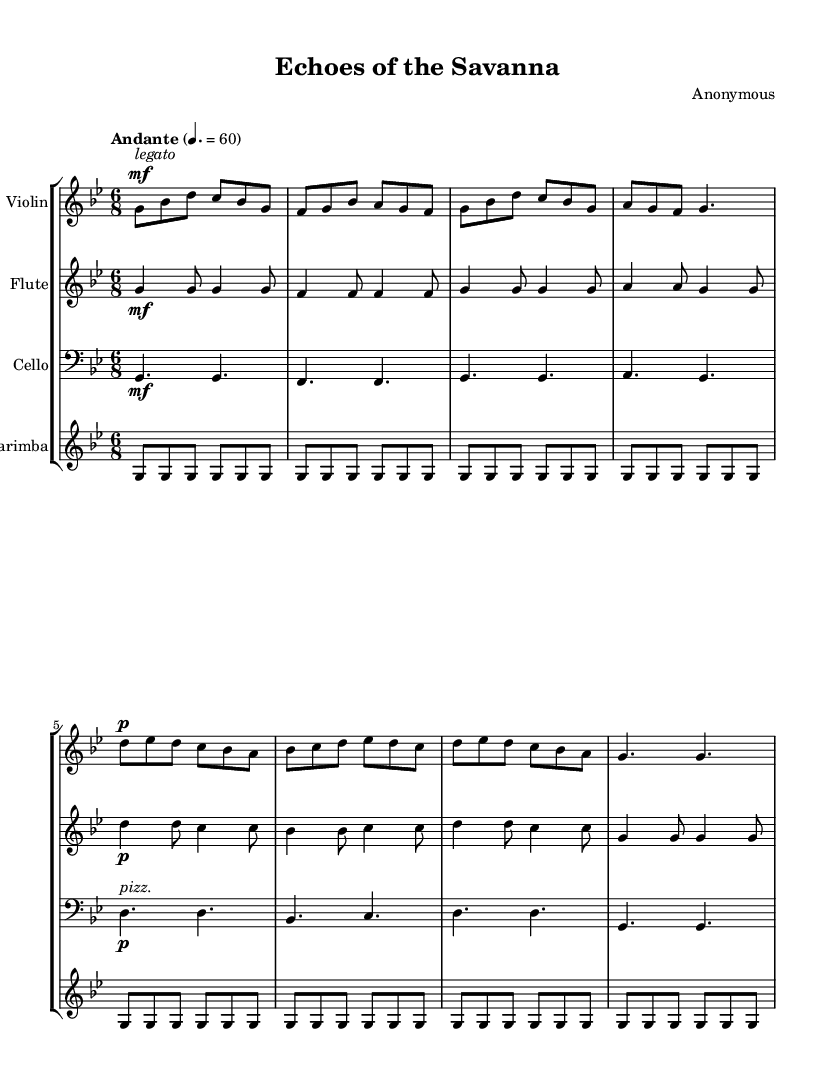What is the key signature of this music? The key signature is indicated by the number of sharps or flats at the beginning of the staffs. In this case, it shows one flat, indicating that the key is G minor.
Answer: G minor What is the time signature of the music? The time signature is shown at the beginning of the composition, displayed as a fraction. Here, it is written as 6/8, indicating that there are six eighth notes per measure.
Answer: 6/8 What is the tempo marking of the piece? The tempo marking is located above the staff and indicates the speed of the music. It states "Andante" with a metronome marking of 60, suggesting a moderate pace.
Answer: Andante, 60 How many instruments are featured in this composition? The score includes separate staves for each instrument. By counting the staves, we find there are four distinct instruments: Violin, Flute, Cello, and Marimba.
Answer: Four Which instrument plays the lowest pitch in the score? The cello is indicated to be in the bass clef, which is generally lower than the treble clef instruments represented by the violin and flute. It has the lowest note at the beginning of its section.
Answer: Cello How would you describe the dynamic markings of the violin part? The dynamic marking starts with "mf" (mezzo-forte) at the beginning and then indicates a "p" (piano) at a different point, showing a contrast in volume throughout the piece.
Answer: mf, p What is the stylistic influence evident in this composition? The title "Echoes of the Savanna" along with the use of marimba suggests a strong influence from traditional African folk melodies, reflecting both the instrumentation and thematic concerns.
Answer: Traditional African folk melodies 